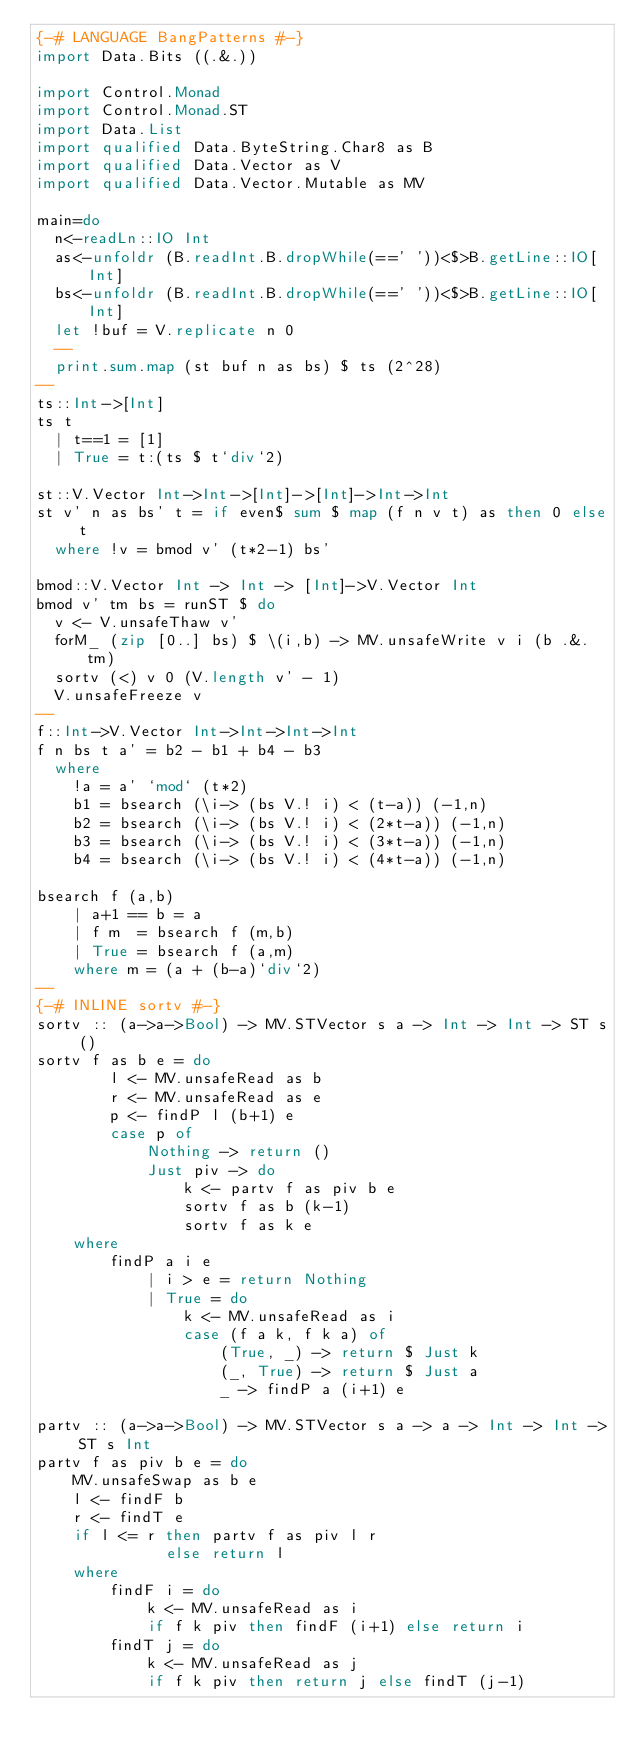<code> <loc_0><loc_0><loc_500><loc_500><_Haskell_>{-# LANGUAGE BangPatterns #-}
import Data.Bits ((.&.))

import Control.Monad
import Control.Monad.ST
import Data.List
import qualified Data.ByteString.Char8 as B
import qualified Data.Vector as V
import qualified Data.Vector.Mutable as MV

main=do
  n<-readLn::IO Int
  as<-unfoldr (B.readInt.B.dropWhile(==' '))<$>B.getLine::IO[Int]
  bs<-unfoldr (B.readInt.B.dropWhile(==' '))<$>B.getLine::IO[Int]
  let !buf = V.replicate n 0
  --
  print.sum.map (st buf n as bs) $ ts (2^28)
--
ts::Int->[Int]
ts t
  | t==1 = [1]
  | True = t:(ts $ t`div`2)

st::V.Vector Int->Int->[Int]->[Int]->Int->Int
st v' n as bs' t = if even$ sum $ map (f n v t) as then 0 else t
  where !v = bmod v' (t*2-1) bs'

bmod::V.Vector Int -> Int -> [Int]->V.Vector Int
bmod v' tm bs = runST $ do
  v <- V.unsafeThaw v'
  forM_ (zip [0..] bs) $ \(i,b) -> MV.unsafeWrite v i (b .&. tm)
  sortv (<) v 0 (V.length v' - 1)
  V.unsafeFreeze v
--
f::Int->V.Vector Int->Int->Int->Int
f n bs t a' = b2 - b1 + b4 - b3
  where
    !a = a' `mod` (t*2)
    b1 = bsearch (\i-> (bs V.! i) < (t-a)) (-1,n)
    b2 = bsearch (\i-> (bs V.! i) < (2*t-a)) (-1,n)
    b3 = bsearch (\i-> (bs V.! i) < (3*t-a)) (-1,n)
    b4 = bsearch (\i-> (bs V.! i) < (4*t-a)) (-1,n)

bsearch f (a,b)
    | a+1 == b = a
    | f m  = bsearch f (m,b)
    | True = bsearch f (a,m)
    where m = (a + (b-a)`div`2)
--
{-# INLINE sortv #-}
sortv :: (a->a->Bool) -> MV.STVector s a -> Int -> Int -> ST s ()
sortv f as b e = do
        l <- MV.unsafeRead as b
        r <- MV.unsafeRead as e
        p <- findP l (b+1) e
        case p of
            Nothing -> return ()
            Just piv -> do
                k <- partv f as piv b e
                sortv f as b (k-1)
                sortv f as k e
    where
        findP a i e
            | i > e = return Nothing
            | True = do
                k <- MV.unsafeRead as i
                case (f a k, f k a) of
                    (True, _) -> return $ Just k
                    (_, True) -> return $ Just a
                    _ -> findP a (i+1) e

partv :: (a->a->Bool) -> MV.STVector s a -> a -> Int -> Int -> ST s Int
partv f as piv b e = do
    MV.unsafeSwap as b e
    l <- findF b
    r <- findT e
    if l <= r then partv f as piv l r
              else return l
    where
        findF i = do
            k <- MV.unsafeRead as i
            if f k piv then findF (i+1) else return i
        findT j = do
            k <- MV.unsafeRead as j
            if f k piv then return j else findT (j-1)
</code> 